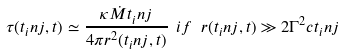<formula> <loc_0><loc_0><loc_500><loc_500>\tau ( t _ { i } n j , t ) \simeq \frac { \kappa \dot { M } t _ { i } n j } { 4 \pi r ^ { 2 } ( t _ { i } n j , t ) } \ i f \ r ( t _ { i } n j , t ) \gg 2 \Gamma ^ { 2 } c t _ { i } n j</formula> 